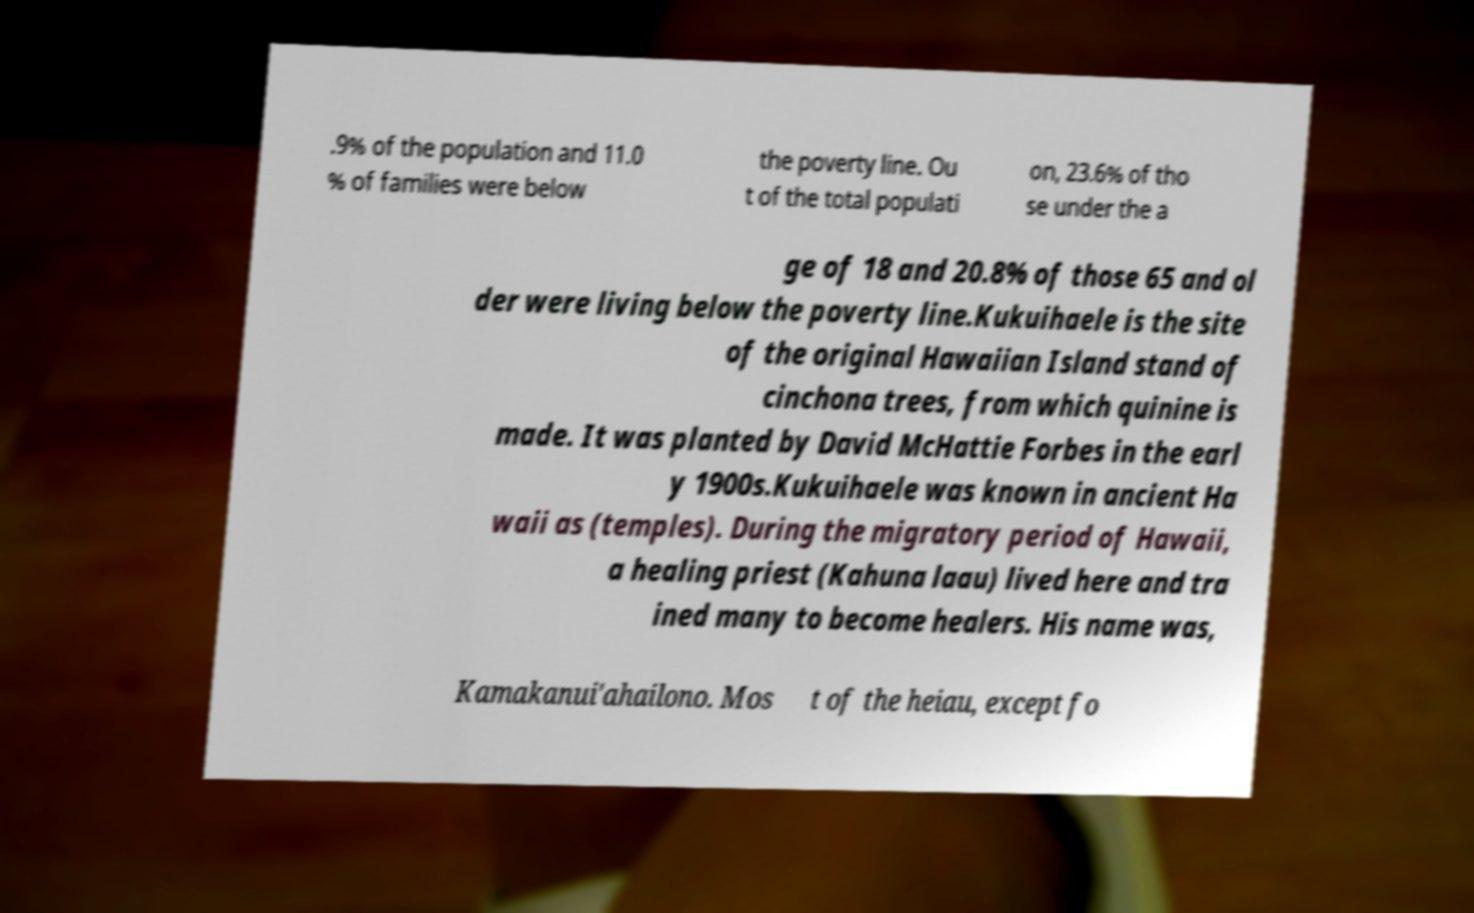I need the written content from this picture converted into text. Can you do that? .9% of the population and 11.0 % of families were below the poverty line. Ou t of the total populati on, 23.6% of tho se under the a ge of 18 and 20.8% of those 65 and ol der were living below the poverty line.Kukuihaele is the site of the original Hawaiian Island stand of cinchona trees, from which quinine is made. It was planted by David McHattie Forbes in the earl y 1900s.Kukuihaele was known in ancient Ha waii as (temples). During the migratory period of Hawaii, a healing priest (Kahuna laau) lived here and tra ined many to become healers. His name was, Kamakanui'ahailono. Mos t of the heiau, except fo 